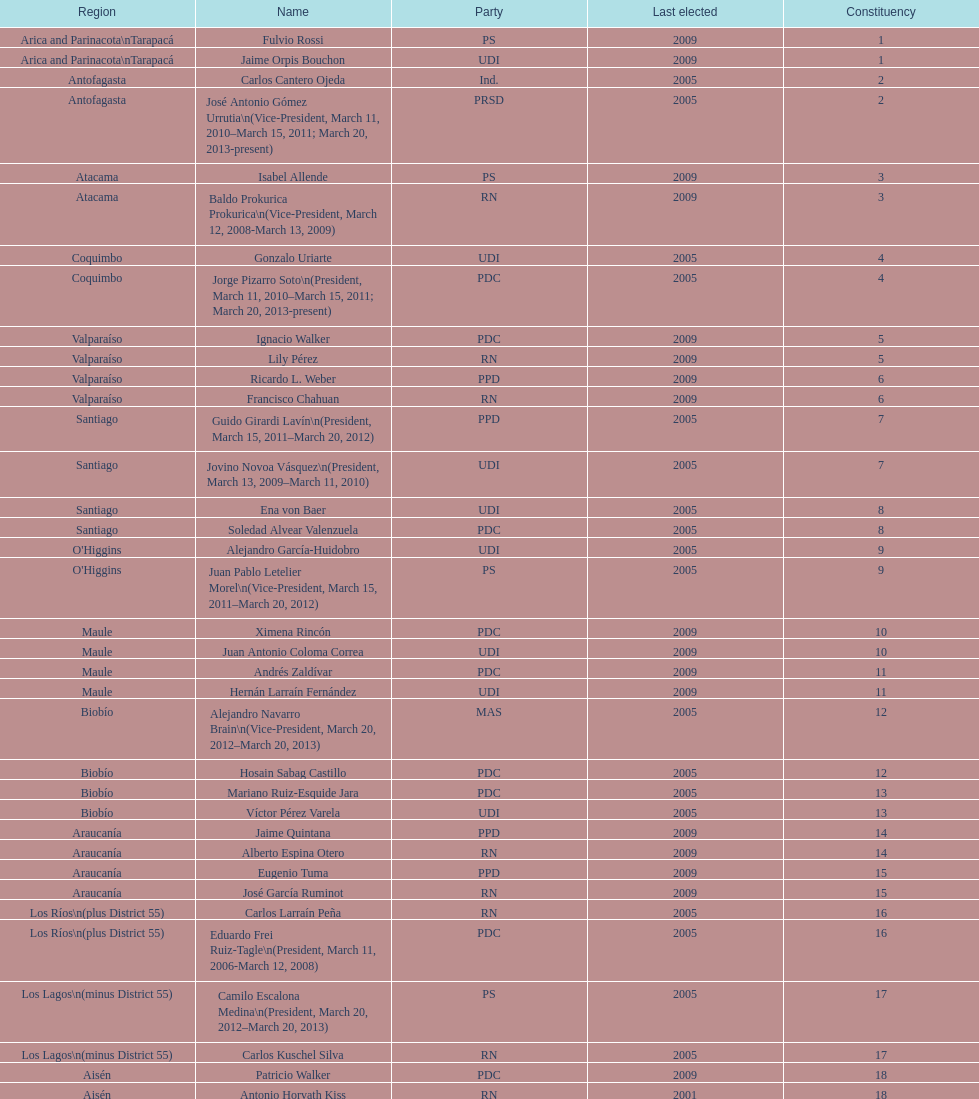When was antonio horvath kiss last elected? 2001. 